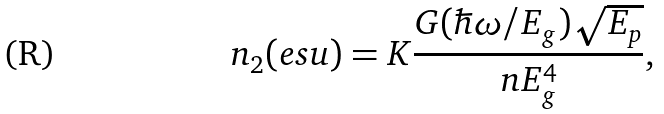Convert formula to latex. <formula><loc_0><loc_0><loc_500><loc_500>n _ { 2 } ( e s u ) = K \frac { { G ( \hbar { \omega } / E _ { g } ) \sqrt { E _ { p } } } } { n E _ { g } ^ { 4 } } ,</formula> 